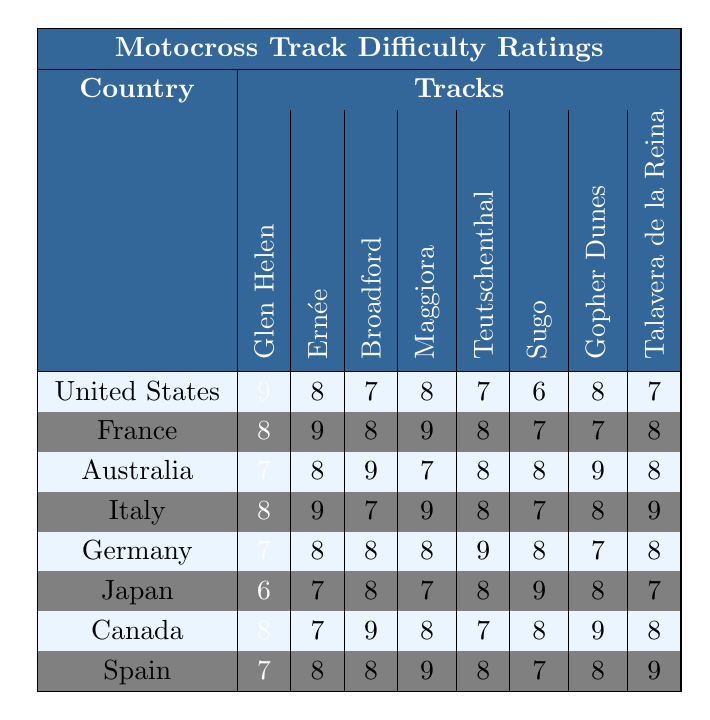What is the hardest track in the United States? In the table, the hardest track is indicated by the highest difficulty rating. For the United States, Glen Helen has a rating of 9, which is the highest compared to other tracks listed under the United States.
Answer: Glen Helen Which country has the most tracks rated 9? To answer this, look at each country's track ratings for the number of times the value 9 appears. France has three tracks rated 9 (Ernée, Maggiora, and Italy). No other country has three tracks rated 9.
Answer: France What is the average difficulty rating of tracks in Australia? To calculate the average, sum the ratings for Australia's tracks (7 + 8 + 9 + 7 + 8 + 8 + 9 + 8) which equals 66. There are 8 tracks, so the average would be 66/8 = 8.25.
Answer: 8.25 Is the Sugo track in Japan harder than the Gopher Dunes track in Canada? To compare, check the difficulty ratings for Sugo and Gopher Dunes. Sugo has a rating of 9, while Gopher Dunes has a rating of 9, which means they are equally rated.
Answer: No What is the difference between the highest and lowest ratings for tracks in Germany? First, find the highest rating (9) and the lowest rating (7) for Germany's tracks. The difference is calculated by subtracting the lowest from the highest (9 - 7 = 2).
Answer: 2 Which country has the lowest difficulty rating for any of its tracks? Check the ratings for each country, identifying the lowest score. Japan has the lowest score of 6 for Sugo.
Answer: Japan Which country has the highest difficulty rating for Maggiora? Look at the ratings for Maggiora across the countries. Italy has the highest rating of 9 for Maggiora.
Answer: Italy How many countries have a track rated 8 in Glen Helen? Check the Glen Helen track ratings for each country. The United States is the only country with Glen Helen rated 9. No other tracks under Glen Helen have a rating of 8.
Answer: 0 Which track has the highest overall difficulty rating, and what is that rating? To determine this, look for the highest individual rating across all tracks in all countries. The highest rating is 9, appearing in several tracks such as Glen Helen, Ernée, and Maggiora.
Answer: 9 Which two countries have difficulty ratings for Broadford that average out to a rating of 9? The ratings for Broadford are: Australia (9) and Canada (9). To average their ratings, add 9 + 9 = 18 and divide by 2, results in 9.
Answer: Australia and Canada 